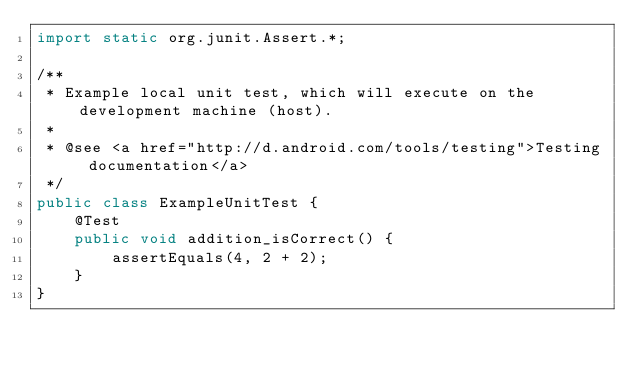<code> <loc_0><loc_0><loc_500><loc_500><_Java_>import static org.junit.Assert.*;

/**
 * Example local unit test, which will execute on the development machine (host).
 *
 * @see <a href="http://d.android.com/tools/testing">Testing documentation</a>
 */
public class ExampleUnitTest {
    @Test
    public void addition_isCorrect() {
        assertEquals(4, 2 + 2);
    }
}</code> 